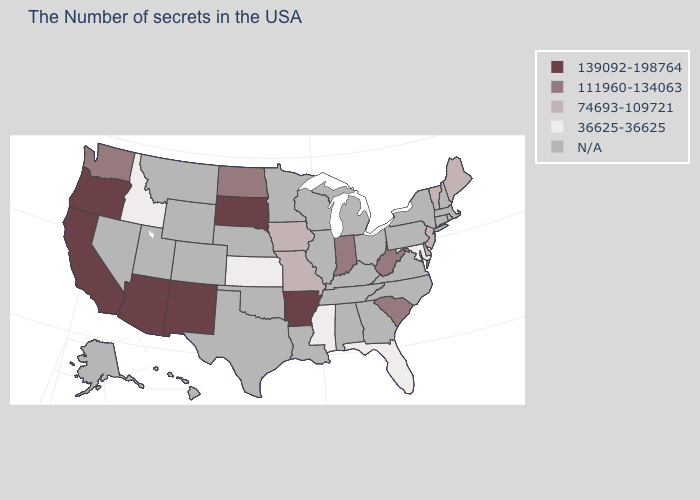What is the value of Oregon?
Give a very brief answer. 139092-198764. Is the legend a continuous bar?
Answer briefly. No. What is the value of New Hampshire?
Give a very brief answer. N/A. What is the value of Georgia?
Short answer required. N/A. What is the value of Colorado?
Short answer required. N/A. Name the states that have a value in the range 36625-36625?
Write a very short answer. Maryland, Florida, Mississippi, Kansas, Idaho. Name the states that have a value in the range N/A?
Be succinct. Massachusetts, Rhode Island, New Hampshire, Connecticut, New York, Delaware, Pennsylvania, Virginia, North Carolina, Ohio, Georgia, Michigan, Kentucky, Alabama, Tennessee, Wisconsin, Illinois, Louisiana, Minnesota, Nebraska, Oklahoma, Texas, Wyoming, Colorado, Utah, Montana, Nevada, Alaska, Hawaii. Which states have the lowest value in the South?
Be succinct. Maryland, Florida, Mississippi. Which states have the lowest value in the USA?
Give a very brief answer. Maryland, Florida, Mississippi, Kansas, Idaho. What is the value of Maryland?
Concise answer only. 36625-36625. Is the legend a continuous bar?
Answer briefly. No. Does the map have missing data?
Keep it brief. Yes. How many symbols are there in the legend?
Keep it brief. 5. What is the lowest value in the USA?
Short answer required. 36625-36625. 